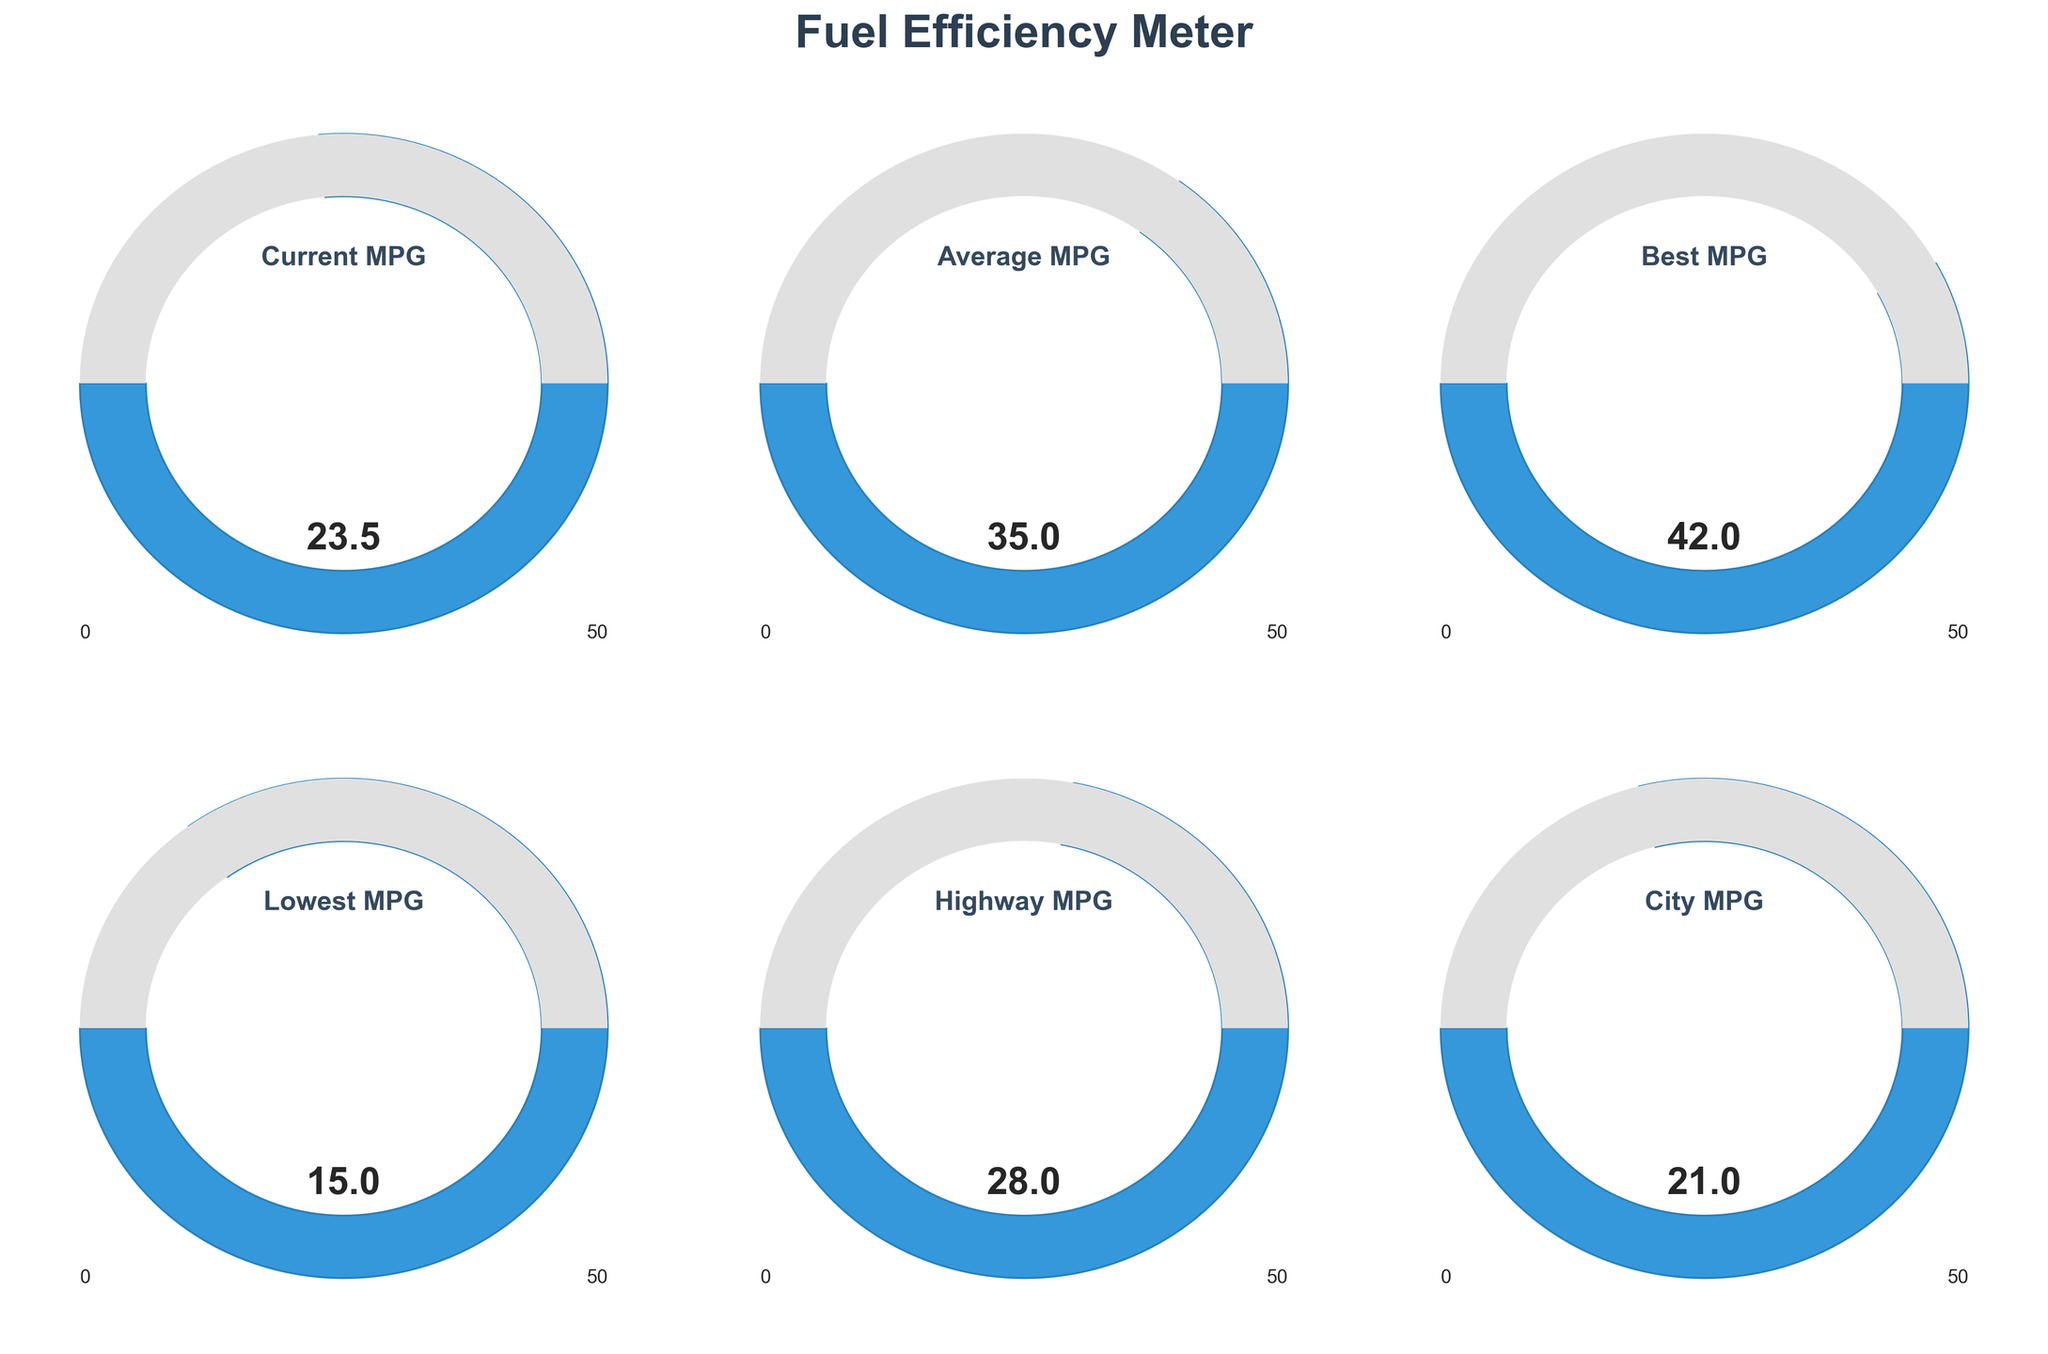What is the highest value displayed on the gauges? The highest value can be found by checking each of the labels. The “Best MPG” gauge shows a value of 42, which is the highest among all the gauges.
Answer: 42 What is the current miles per gallon (MPG) displayed? The current miles per gallon is shown on the gauge labeled “Current MPG.” It reads 23.5 MPG.
Answer: 23.5 Which gauge shows the lowest MPG value? By checking all the values on the gauges, the “Lowest MPG” gauge shows the smallest value of 15.
Answer: 15 How many total gauges are presented in the figure? By counting the total number of individual gauge displays, it is clear there are 6 gauges.
Answer: 6 What is the average value of all the presented MPG readings? The values presented are 23.5, 35, 42, 15, 28, and 21. Summing them up, we get 164. Dividing by the number of values (6), we find the average value is 164 / 6 ≈ 27.33.
Answer: 27.33 What is the difference between the highest and lowest MPG value shown? The highest value is 42 (Best MPG), and the lowest is 15 (Lowest MPG). Subtracting these values gives 42 - 15 = 27.
Answer: 27 Which is higher: City MPG or Highway MPG? Comparing the values displayed, the City MPG is 21 and Highway MPG is 28. Therefore, Highway MPG is higher.
Answer: Highway MPG What color is used to fill the gauge wedges? Observing the visual appearance of the gauge wedges, they are filled with a shade of blue.
Answer: Blue What is the average of the Current MPG and Average MPG values? The Current MPG is 23.5, and the Average MPG is 35. Summing these values, we get 23.5 + 35 = 58. Dividing by 2, the average is 58 / 2 = 29.
Answer: 29 Which value is closer to the mid-point of the MPG scale (25): Current MPG or City MPG? The mid-point of the MPG scale is 25. The difference between Current MPG (23.5) and 25 is 1.5, and the difference between City MPG (21) and 25 is 4. Therefore, Current MPG is closer to 25.
Answer: Current MPG 